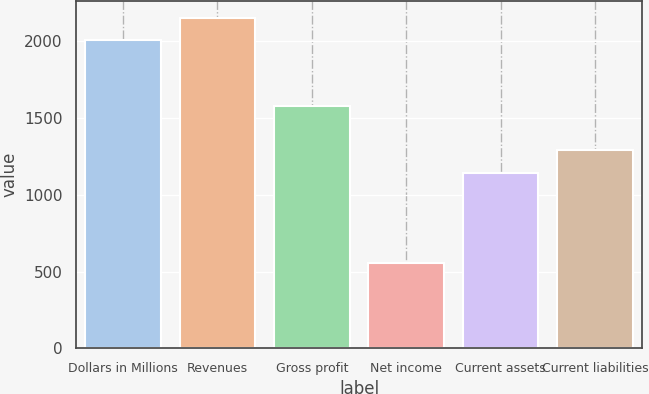<chart> <loc_0><loc_0><loc_500><loc_500><bar_chart><fcel>Dollars in Millions<fcel>Revenues<fcel>Gross profit<fcel>Net income<fcel>Current assets<fcel>Current liabilities<nl><fcel>2004<fcel>2151.9<fcel>1576<fcel>559<fcel>1142<fcel>1289.9<nl></chart> 